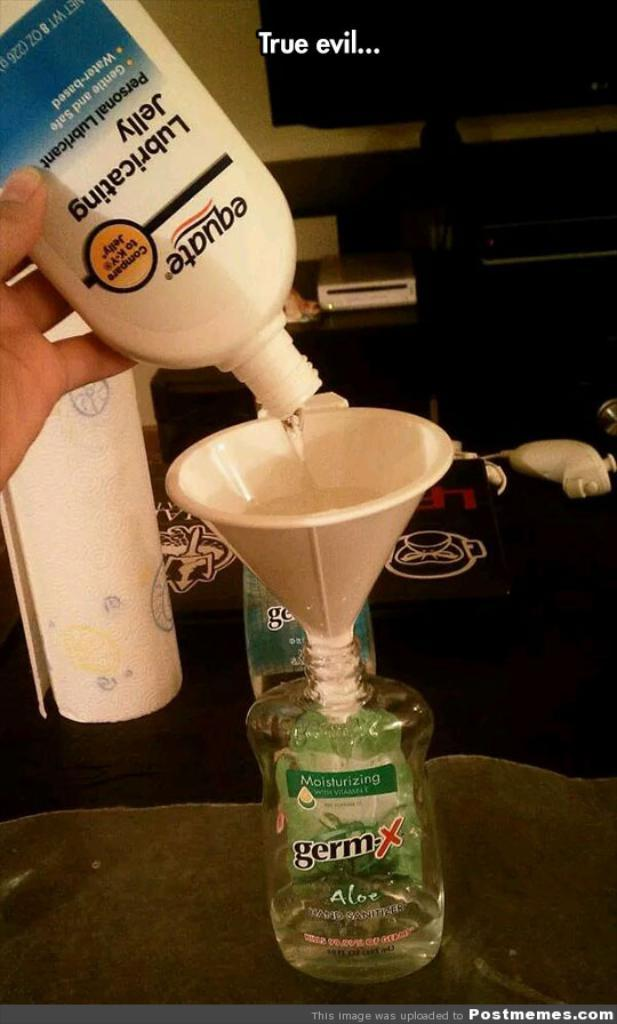What object is on the table in the image? There is a bottle on a table in the image. What is the person in the image doing with the bottle? The person is pouring liquid into the bottle. What can be seen in the background of the image? There is a TV and another table in the background. What time is the train scheduled to arrive in the image? There is no train present in the image, so it is not possible to determine the arrival time of a train. 